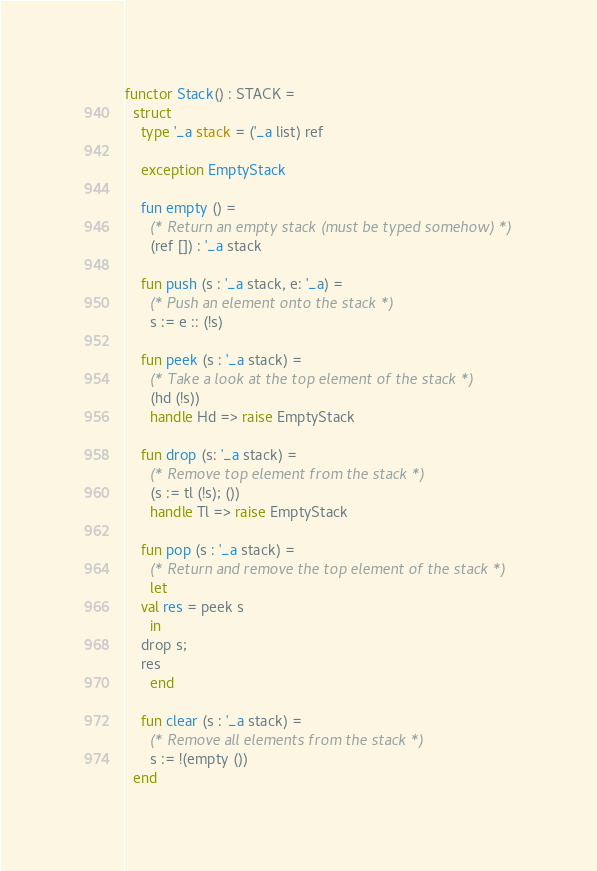<code> <loc_0><loc_0><loc_500><loc_500><_SML_>
functor Stack() : STACK =
  struct
    type '_a stack = ('_a list) ref
      
    exception EmptyStack

    fun empty () = 
      (* Return an empty stack (must be typed somehow) *)
      (ref []) : '_a stack

    fun push (s : '_a stack, e: '_a) =
      (* Push an element onto the stack *)
      s := e :: (!s)
      
    fun peek (s : '_a stack) =
      (* Take a look at the top element of the stack *)
      (hd (!s))
      handle Hd => raise EmptyStack

    fun drop (s: '_a stack) =
      (* Remove top element from the stack *)
      (s := tl (!s); ())
      handle Tl => raise EmptyStack

    fun pop (s : '_a stack) =
      (* Return and remove the top element of the stack *)
      let
	val res = peek s
      in
	drop s;
	res
      end
    
    fun clear (s : '_a stack) =
      (* Remove all elements from the stack *)
      s := !(empty ())
  end
</code> 